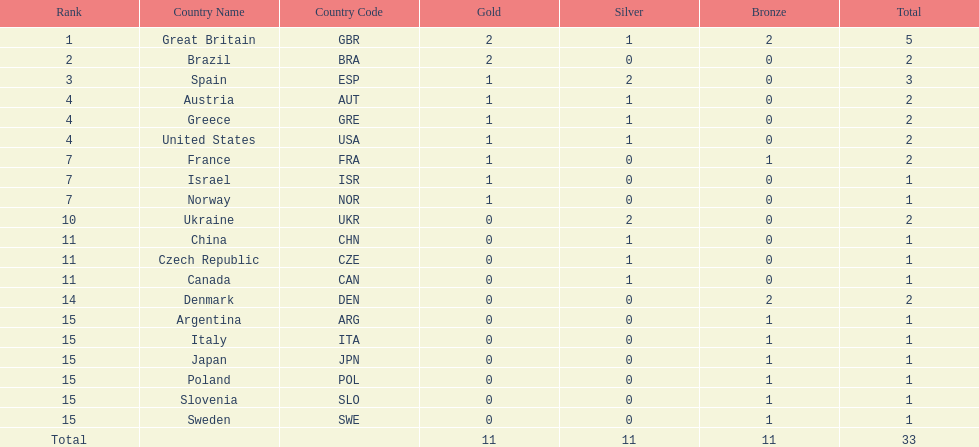Who won more gold medals than spain? Great Britain (GBR), Brazil (BRA). 